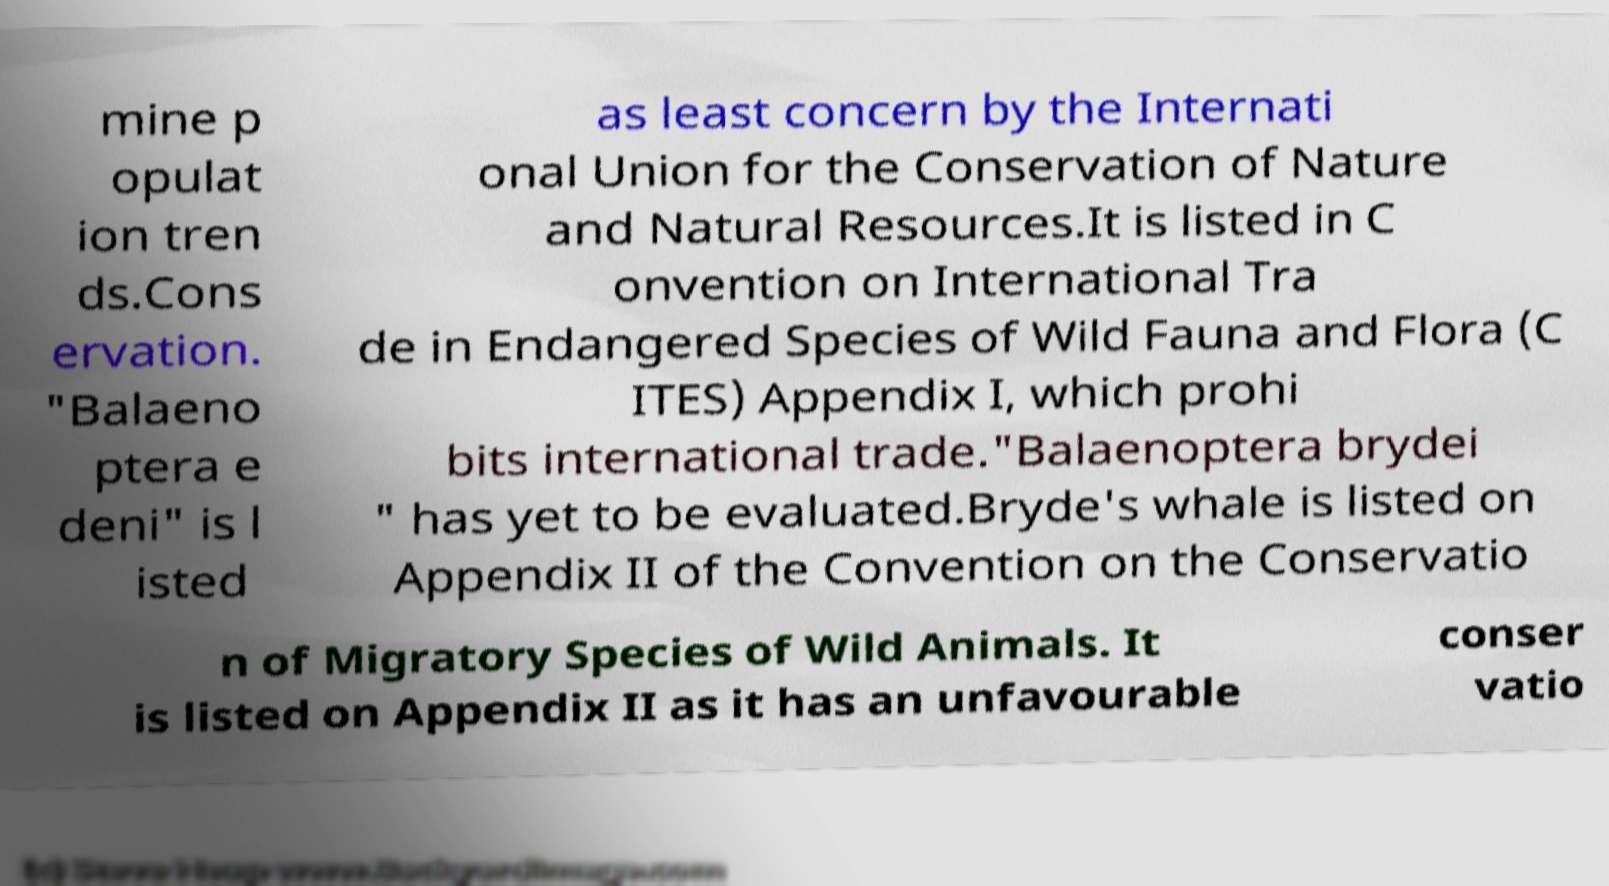There's text embedded in this image that I need extracted. Can you transcribe it verbatim? mine p opulat ion tren ds.Cons ervation. "Balaeno ptera e deni" is l isted as least concern by the Internati onal Union for the Conservation of Nature and Natural Resources.It is listed in C onvention on International Tra de in Endangered Species of Wild Fauna and Flora (C ITES) Appendix I, which prohi bits international trade."Balaenoptera brydei " has yet to be evaluated.Bryde's whale is listed on Appendix II of the Convention on the Conservatio n of Migratory Species of Wild Animals. It is listed on Appendix II as it has an unfavourable conser vatio 